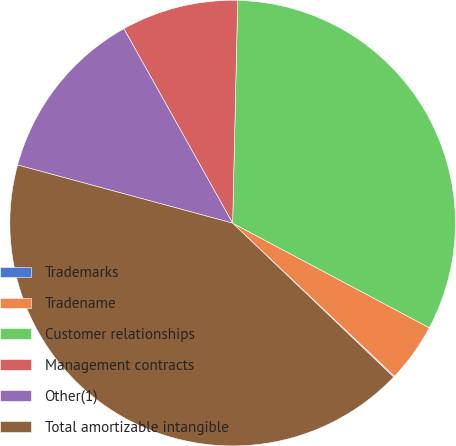<chart> <loc_0><loc_0><loc_500><loc_500><pie_chart><fcel>Trademarks<fcel>Tradename<fcel>Customer relationships<fcel>Management contracts<fcel>Other(1)<fcel>Total amortizable intangible<nl><fcel>0.08%<fcel>4.28%<fcel>32.42%<fcel>8.48%<fcel>12.68%<fcel>42.06%<nl></chart> 